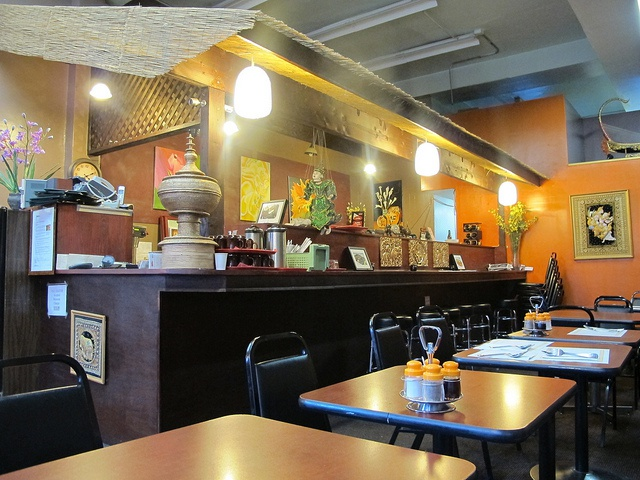Describe the objects in this image and their specific colors. I can see dining table in gray, black, tan, khaki, and brown tones, dining table in gray, tan, salmon, and khaki tones, chair in gray, black, and darkblue tones, dining table in gray, black, and lightblue tones, and chair in gray, black, navy, and darkblue tones in this image. 